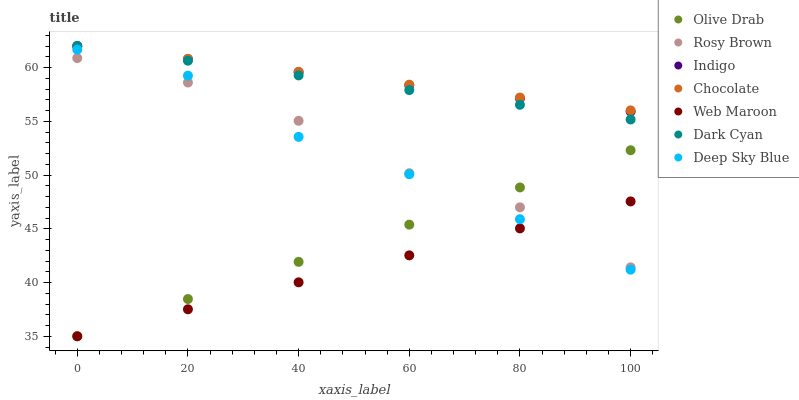Does Web Maroon have the minimum area under the curve?
Answer yes or no. Yes. Does Chocolate have the maximum area under the curve?
Answer yes or no. Yes. Does Rosy Brown have the minimum area under the curve?
Answer yes or no. No. Does Rosy Brown have the maximum area under the curve?
Answer yes or no. No. Is Indigo the smoothest?
Answer yes or no. Yes. Is Rosy Brown the roughest?
Answer yes or no. Yes. Is Web Maroon the smoothest?
Answer yes or no. No. Is Web Maroon the roughest?
Answer yes or no. No. Does Web Maroon have the lowest value?
Answer yes or no. Yes. Does Rosy Brown have the lowest value?
Answer yes or no. No. Does Dark Cyan have the highest value?
Answer yes or no. Yes. Does Rosy Brown have the highest value?
Answer yes or no. No. Is Rosy Brown less than Chocolate?
Answer yes or no. Yes. Is Chocolate greater than Deep Sky Blue?
Answer yes or no. Yes. Does Web Maroon intersect Olive Drab?
Answer yes or no. Yes. Is Web Maroon less than Olive Drab?
Answer yes or no. No. Is Web Maroon greater than Olive Drab?
Answer yes or no. No. Does Rosy Brown intersect Chocolate?
Answer yes or no. No. 